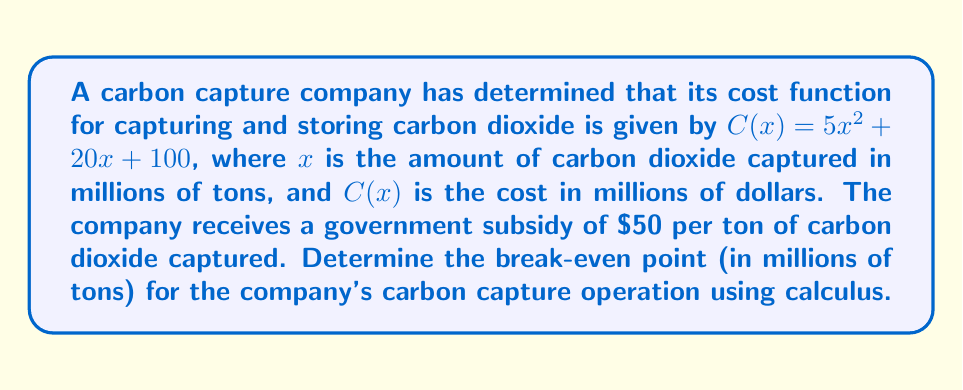Help me with this question. To solve this problem, we need to follow these steps:

1) First, let's define the revenue function. The company receives $50 per ton, which is $50 million per million tons. So the revenue function is:

   $R(x) = 50x$

2) The profit function is revenue minus cost:

   $P(x) = R(x) - C(x) = 50x - (5x^2 + 20x + 100)$
   $P(x) = -5x^2 + 30x - 100$

3) The break-even point occurs when profit is zero. So we need to solve:

   $P(x) = 0$
   $-5x^2 + 30x - 100 = 0$

4) This is a quadratic equation. We can solve it using the quadratic formula:

   $x = \frac{-b \pm \sqrt{b^2 - 4ac}}{2a}$

   Where $a = -5$, $b = 30$, and $c = -100$

5) Substituting these values:

   $x = \frac{-30 \pm \sqrt{30^2 - 4(-5)(-100)}}{2(-5)}$
   $x = \frac{-30 \pm \sqrt{900 - 2000}}{-10}$
   $x = \frac{-30 \pm \sqrt{-1100}}{-10}$

6) Since we're dealing with real quantities, we can discard the negative square root. There is no real solution in this case.

7) However, we can find the maximum profit point using calculus. The derivative of the profit function is:

   $P'(x) = -10x + 30$

8) Setting this to zero:

   $-10x + 30 = 0$
   $x = 3$

9) This is the point of maximum profit. The second derivative $P''(x) = -10$ is negative, confirming this is a maximum.

10) Evaluating the profit function at $x = 3$:

    $P(3) = -5(3)^2 + 30(3) - 100 = -45 + 90 - 100 = -55$

The maximum profit is negative, which means the company never breaks even under these conditions.
Answer: There is no break-even point. The company operates at a loss for all levels of carbon capture under the given cost structure and subsidy. 